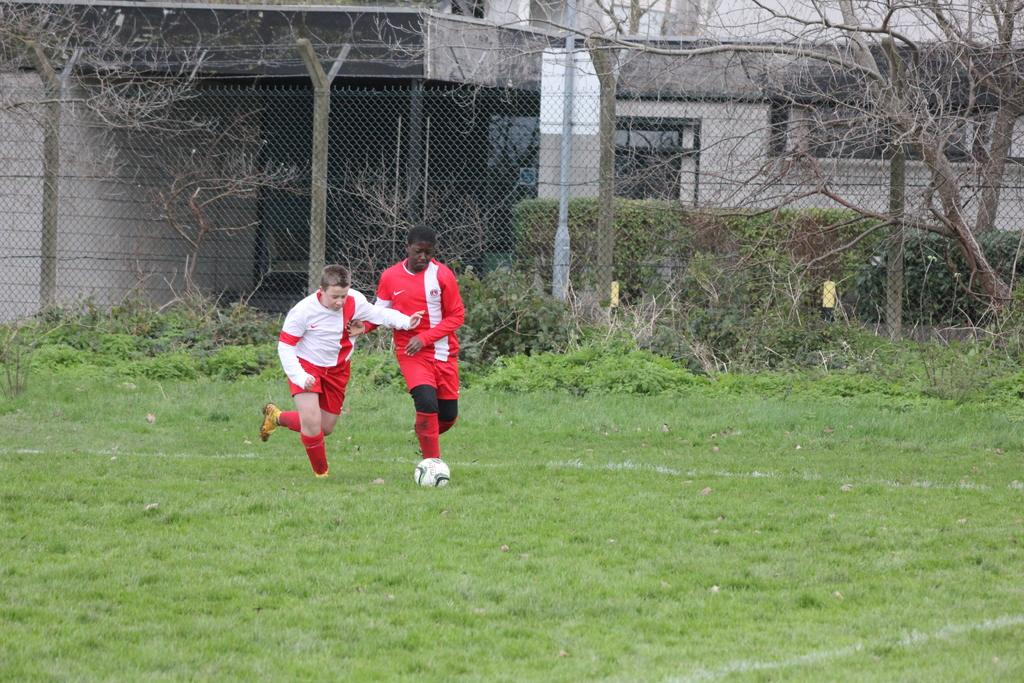What are the two persons in the image doing? The two persons are playing football. What can be seen in the background of the image? There is a fence, trees, and buildings in the image. What type of nose can be seen on the football in the image? There is no nose present on the football in the image, as footballs do not have noses. 